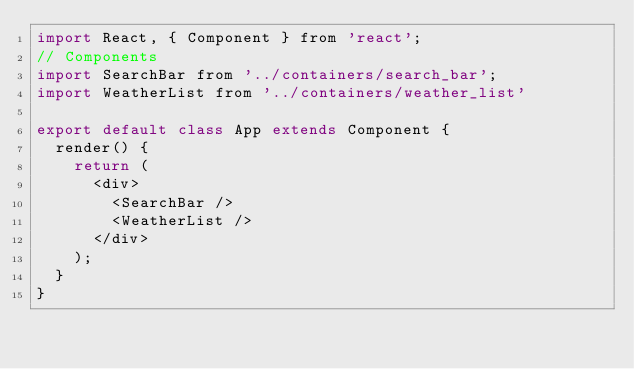<code> <loc_0><loc_0><loc_500><loc_500><_JavaScript_>import React, { Component } from 'react';
// Components
import SearchBar from '../containers/search_bar';
import WeatherList from '../containers/weather_list'

export default class App extends Component {
  render() {
    return (
      <div>
        <SearchBar />
        <WeatherList />
      </div>
    );
  }
}
</code> 